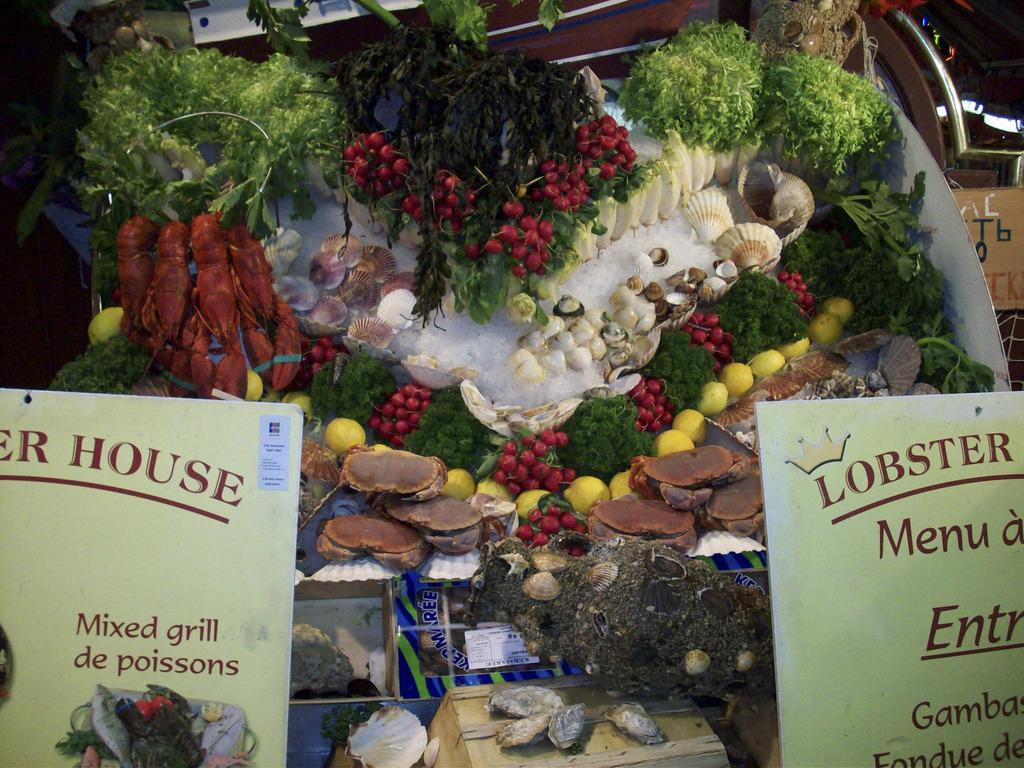Could you give a brief overview of what you see in this image? In this picture I can see the boards in front on which there is something written and in the background I see number of shells, fruits and other green things. 